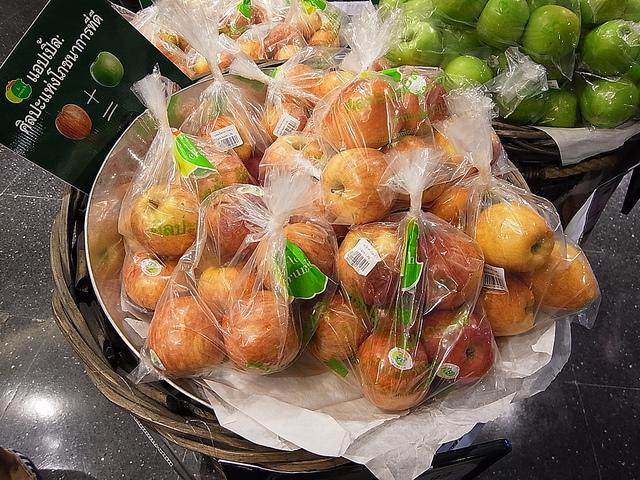What language is shown?
Concise answer only. Russian. What kind of containers are the apples in?
Quick response, please. Plastic bags. How many pictures of apples are there in this scene?
Write a very short answer. 1. 